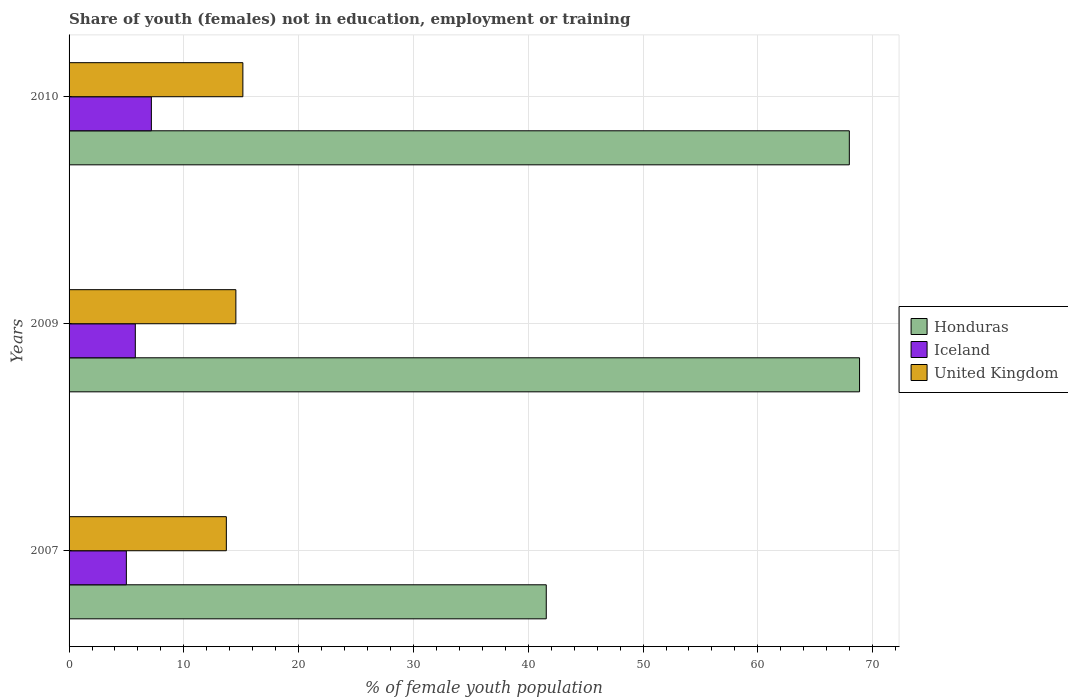Are the number of bars on each tick of the Y-axis equal?
Provide a short and direct response. Yes. How many bars are there on the 3rd tick from the bottom?
Keep it short and to the point. 3. What is the label of the 3rd group of bars from the top?
Keep it short and to the point. 2007. What is the percentage of unemployed female population in in Iceland in 2010?
Provide a short and direct response. 7.17. Across all years, what is the maximum percentage of unemployed female population in in Honduras?
Provide a succinct answer. 68.86. Across all years, what is the minimum percentage of unemployed female population in in Honduras?
Keep it short and to the point. 41.57. In which year was the percentage of unemployed female population in in Honduras maximum?
Your response must be concise. 2009. What is the total percentage of unemployed female population in in Iceland in the graph?
Your answer should be compact. 17.93. What is the difference between the percentage of unemployed female population in in United Kingdom in 2007 and that in 2010?
Provide a succinct answer. -1.44. What is the difference between the percentage of unemployed female population in in Honduras in 2010 and the percentage of unemployed female population in in United Kingdom in 2007?
Offer a terse response. 54.27. What is the average percentage of unemployed female population in in Honduras per year?
Ensure brevity in your answer.  59.47. In the year 2007, what is the difference between the percentage of unemployed female population in in United Kingdom and percentage of unemployed female population in in Iceland?
Give a very brief answer. 8.71. In how many years, is the percentage of unemployed female population in in United Kingdom greater than 56 %?
Your answer should be very brief. 0. What is the ratio of the percentage of unemployed female population in in Iceland in 2009 to that in 2010?
Your answer should be very brief. 0.8. Is the difference between the percentage of unemployed female population in in United Kingdom in 2009 and 2010 greater than the difference between the percentage of unemployed female population in in Iceland in 2009 and 2010?
Offer a very short reply. Yes. What is the difference between the highest and the second highest percentage of unemployed female population in in Honduras?
Offer a terse response. 0.89. What is the difference between the highest and the lowest percentage of unemployed female population in in United Kingdom?
Your answer should be very brief. 1.44. How many bars are there?
Offer a very short reply. 9. Are all the bars in the graph horizontal?
Your response must be concise. Yes. How many years are there in the graph?
Provide a short and direct response. 3. What is the title of the graph?
Your answer should be compact. Share of youth (females) not in education, employment or training. Does "St. Martin (French part)" appear as one of the legend labels in the graph?
Offer a terse response. No. What is the label or title of the X-axis?
Your answer should be compact. % of female youth population. What is the % of female youth population of Honduras in 2007?
Provide a short and direct response. 41.57. What is the % of female youth population in Iceland in 2007?
Keep it short and to the point. 4.99. What is the % of female youth population in United Kingdom in 2007?
Offer a very short reply. 13.7. What is the % of female youth population of Honduras in 2009?
Your answer should be very brief. 68.86. What is the % of female youth population in Iceland in 2009?
Ensure brevity in your answer.  5.77. What is the % of female youth population in United Kingdom in 2009?
Provide a short and direct response. 14.53. What is the % of female youth population in Honduras in 2010?
Your response must be concise. 67.97. What is the % of female youth population in Iceland in 2010?
Provide a succinct answer. 7.17. What is the % of female youth population of United Kingdom in 2010?
Provide a short and direct response. 15.14. Across all years, what is the maximum % of female youth population of Honduras?
Ensure brevity in your answer.  68.86. Across all years, what is the maximum % of female youth population of Iceland?
Keep it short and to the point. 7.17. Across all years, what is the maximum % of female youth population in United Kingdom?
Make the answer very short. 15.14. Across all years, what is the minimum % of female youth population in Honduras?
Keep it short and to the point. 41.57. Across all years, what is the minimum % of female youth population of Iceland?
Offer a terse response. 4.99. Across all years, what is the minimum % of female youth population in United Kingdom?
Your answer should be very brief. 13.7. What is the total % of female youth population of Honduras in the graph?
Provide a succinct answer. 178.4. What is the total % of female youth population of Iceland in the graph?
Ensure brevity in your answer.  17.93. What is the total % of female youth population of United Kingdom in the graph?
Your response must be concise. 43.37. What is the difference between the % of female youth population in Honduras in 2007 and that in 2009?
Your answer should be compact. -27.29. What is the difference between the % of female youth population of Iceland in 2007 and that in 2009?
Provide a succinct answer. -0.78. What is the difference between the % of female youth population of United Kingdom in 2007 and that in 2009?
Offer a very short reply. -0.83. What is the difference between the % of female youth population in Honduras in 2007 and that in 2010?
Give a very brief answer. -26.4. What is the difference between the % of female youth population in Iceland in 2007 and that in 2010?
Your answer should be compact. -2.18. What is the difference between the % of female youth population of United Kingdom in 2007 and that in 2010?
Provide a short and direct response. -1.44. What is the difference between the % of female youth population of Honduras in 2009 and that in 2010?
Give a very brief answer. 0.89. What is the difference between the % of female youth population of Iceland in 2009 and that in 2010?
Offer a very short reply. -1.4. What is the difference between the % of female youth population of United Kingdom in 2009 and that in 2010?
Offer a very short reply. -0.61. What is the difference between the % of female youth population in Honduras in 2007 and the % of female youth population in Iceland in 2009?
Give a very brief answer. 35.8. What is the difference between the % of female youth population in Honduras in 2007 and the % of female youth population in United Kingdom in 2009?
Give a very brief answer. 27.04. What is the difference between the % of female youth population of Iceland in 2007 and the % of female youth population of United Kingdom in 2009?
Keep it short and to the point. -9.54. What is the difference between the % of female youth population in Honduras in 2007 and the % of female youth population in Iceland in 2010?
Ensure brevity in your answer.  34.4. What is the difference between the % of female youth population in Honduras in 2007 and the % of female youth population in United Kingdom in 2010?
Your answer should be very brief. 26.43. What is the difference between the % of female youth population of Iceland in 2007 and the % of female youth population of United Kingdom in 2010?
Offer a terse response. -10.15. What is the difference between the % of female youth population in Honduras in 2009 and the % of female youth population in Iceland in 2010?
Keep it short and to the point. 61.69. What is the difference between the % of female youth population of Honduras in 2009 and the % of female youth population of United Kingdom in 2010?
Your response must be concise. 53.72. What is the difference between the % of female youth population of Iceland in 2009 and the % of female youth population of United Kingdom in 2010?
Your answer should be very brief. -9.37. What is the average % of female youth population in Honduras per year?
Your answer should be very brief. 59.47. What is the average % of female youth population of Iceland per year?
Ensure brevity in your answer.  5.98. What is the average % of female youth population of United Kingdom per year?
Make the answer very short. 14.46. In the year 2007, what is the difference between the % of female youth population of Honduras and % of female youth population of Iceland?
Ensure brevity in your answer.  36.58. In the year 2007, what is the difference between the % of female youth population in Honduras and % of female youth population in United Kingdom?
Provide a short and direct response. 27.87. In the year 2007, what is the difference between the % of female youth population of Iceland and % of female youth population of United Kingdom?
Your answer should be compact. -8.71. In the year 2009, what is the difference between the % of female youth population in Honduras and % of female youth population in Iceland?
Keep it short and to the point. 63.09. In the year 2009, what is the difference between the % of female youth population of Honduras and % of female youth population of United Kingdom?
Keep it short and to the point. 54.33. In the year 2009, what is the difference between the % of female youth population of Iceland and % of female youth population of United Kingdom?
Provide a succinct answer. -8.76. In the year 2010, what is the difference between the % of female youth population in Honduras and % of female youth population in Iceland?
Your response must be concise. 60.8. In the year 2010, what is the difference between the % of female youth population of Honduras and % of female youth population of United Kingdom?
Give a very brief answer. 52.83. In the year 2010, what is the difference between the % of female youth population of Iceland and % of female youth population of United Kingdom?
Give a very brief answer. -7.97. What is the ratio of the % of female youth population in Honduras in 2007 to that in 2009?
Provide a succinct answer. 0.6. What is the ratio of the % of female youth population in Iceland in 2007 to that in 2009?
Offer a very short reply. 0.86. What is the ratio of the % of female youth population in United Kingdom in 2007 to that in 2009?
Give a very brief answer. 0.94. What is the ratio of the % of female youth population of Honduras in 2007 to that in 2010?
Your answer should be very brief. 0.61. What is the ratio of the % of female youth population of Iceland in 2007 to that in 2010?
Your answer should be compact. 0.7. What is the ratio of the % of female youth population in United Kingdom in 2007 to that in 2010?
Ensure brevity in your answer.  0.9. What is the ratio of the % of female youth population in Honduras in 2009 to that in 2010?
Provide a succinct answer. 1.01. What is the ratio of the % of female youth population of Iceland in 2009 to that in 2010?
Ensure brevity in your answer.  0.8. What is the ratio of the % of female youth population of United Kingdom in 2009 to that in 2010?
Keep it short and to the point. 0.96. What is the difference between the highest and the second highest % of female youth population in Honduras?
Keep it short and to the point. 0.89. What is the difference between the highest and the second highest % of female youth population of United Kingdom?
Your response must be concise. 0.61. What is the difference between the highest and the lowest % of female youth population in Honduras?
Provide a succinct answer. 27.29. What is the difference between the highest and the lowest % of female youth population of Iceland?
Your response must be concise. 2.18. What is the difference between the highest and the lowest % of female youth population of United Kingdom?
Make the answer very short. 1.44. 